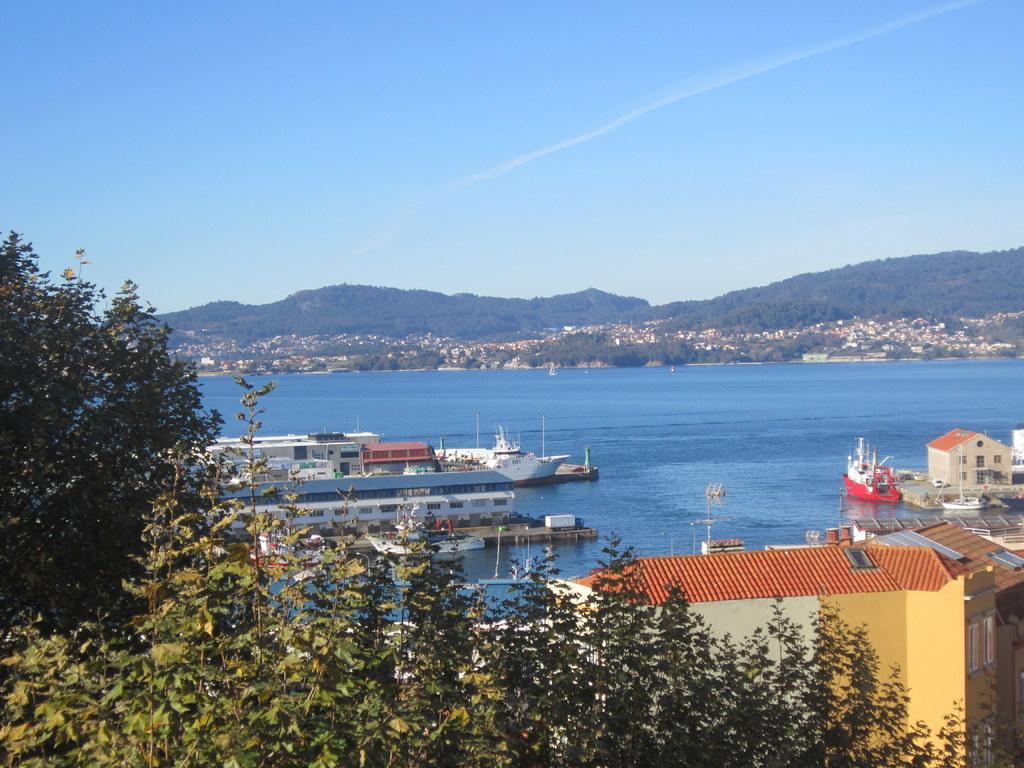Can you describe this image briefly? In this image I can see many ships on the water. To the side of the water I can see many houses. The water are in blue color. In the background there are many trees, mountains and the blue sky. To the left I can also see the trees. 